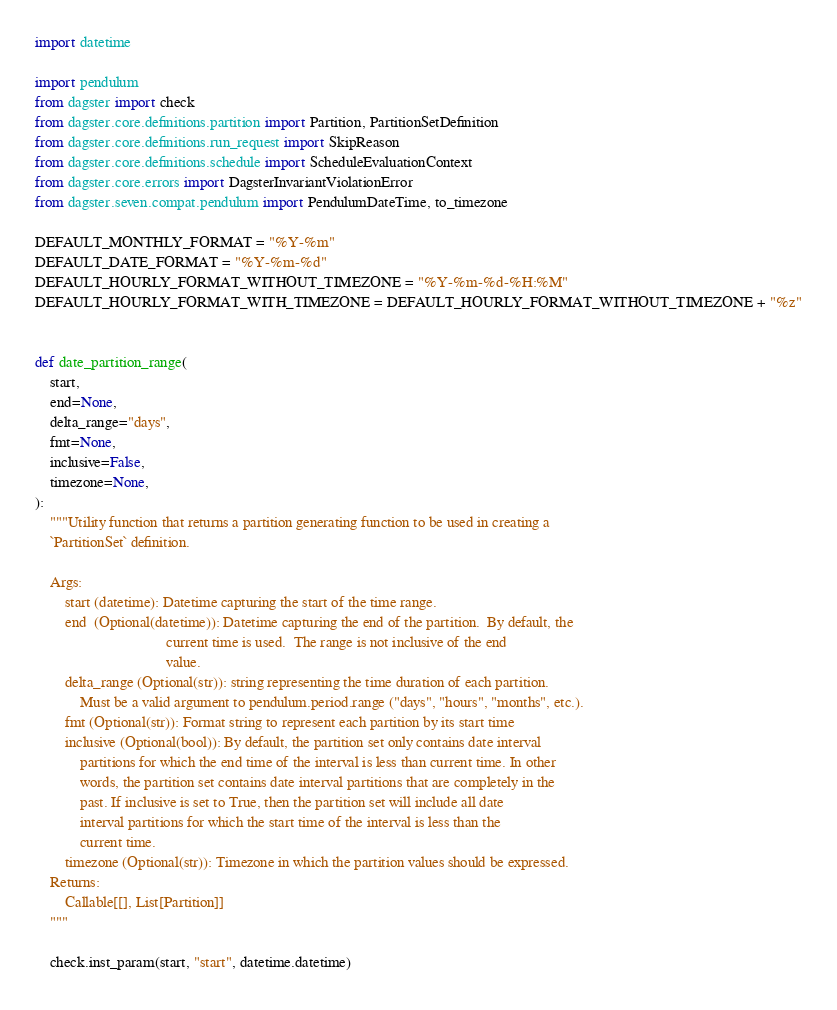<code> <loc_0><loc_0><loc_500><loc_500><_Python_>import datetime

import pendulum
from dagster import check
from dagster.core.definitions.partition import Partition, PartitionSetDefinition
from dagster.core.definitions.run_request import SkipReason
from dagster.core.definitions.schedule import ScheduleEvaluationContext
from dagster.core.errors import DagsterInvariantViolationError
from dagster.seven.compat.pendulum import PendulumDateTime, to_timezone

DEFAULT_MONTHLY_FORMAT = "%Y-%m"
DEFAULT_DATE_FORMAT = "%Y-%m-%d"
DEFAULT_HOURLY_FORMAT_WITHOUT_TIMEZONE = "%Y-%m-%d-%H:%M"
DEFAULT_HOURLY_FORMAT_WITH_TIMEZONE = DEFAULT_HOURLY_FORMAT_WITHOUT_TIMEZONE + "%z"


def date_partition_range(
    start,
    end=None,
    delta_range="days",
    fmt=None,
    inclusive=False,
    timezone=None,
):
    """Utility function that returns a partition generating function to be used in creating a
    `PartitionSet` definition.

    Args:
        start (datetime): Datetime capturing the start of the time range.
        end  (Optional(datetime)): Datetime capturing the end of the partition.  By default, the
                                   current time is used.  The range is not inclusive of the end
                                   value.
        delta_range (Optional(str)): string representing the time duration of each partition.
            Must be a valid argument to pendulum.period.range ("days", "hours", "months", etc.).
        fmt (Optional(str)): Format string to represent each partition by its start time
        inclusive (Optional(bool)): By default, the partition set only contains date interval
            partitions for which the end time of the interval is less than current time. In other
            words, the partition set contains date interval partitions that are completely in the
            past. If inclusive is set to True, then the partition set will include all date
            interval partitions for which the start time of the interval is less than the
            current time.
        timezone (Optional(str)): Timezone in which the partition values should be expressed.
    Returns:
        Callable[[], List[Partition]]
    """

    check.inst_param(start, "start", datetime.datetime)</code> 